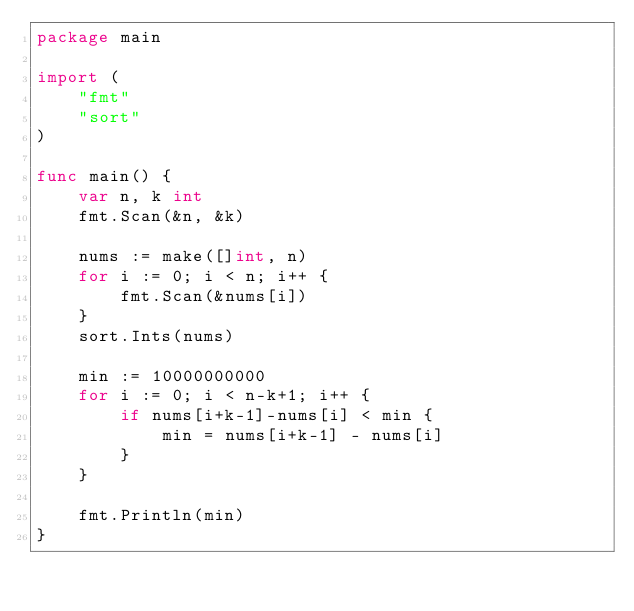Convert code to text. <code><loc_0><loc_0><loc_500><loc_500><_Go_>package main

import (
	"fmt"
	"sort"
)

func main() {
	var n, k int
	fmt.Scan(&n, &k)

	nums := make([]int, n)
	for i := 0; i < n; i++ {
		fmt.Scan(&nums[i])
	}
	sort.Ints(nums)

	min := 10000000000
	for i := 0; i < n-k+1; i++ {
		if nums[i+k-1]-nums[i] < min {
			min = nums[i+k-1] - nums[i]
		}
	}

	fmt.Println(min)
}
</code> 